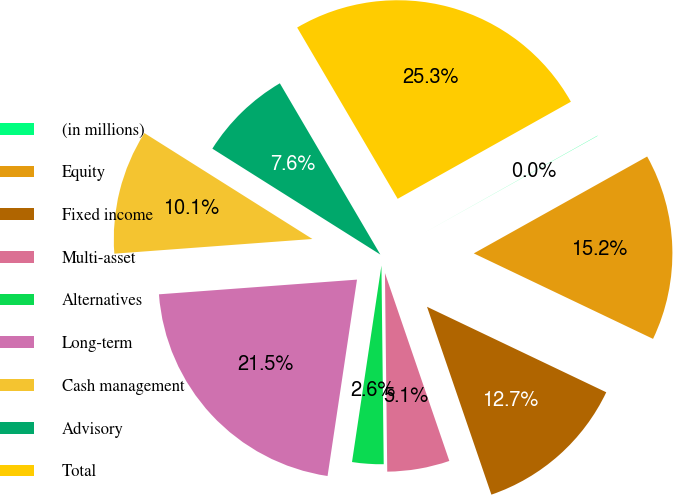Convert chart to OTSL. <chart><loc_0><loc_0><loc_500><loc_500><pie_chart><fcel>(in millions)<fcel>Equity<fcel>Fixed income<fcel>Multi-asset<fcel>Alternatives<fcel>Long-term<fcel>Cash management<fcel>Advisory<fcel>Total<nl><fcel>0.02%<fcel>15.19%<fcel>12.66%<fcel>5.07%<fcel>2.55%<fcel>21.45%<fcel>10.13%<fcel>7.6%<fcel>25.31%<nl></chart> 